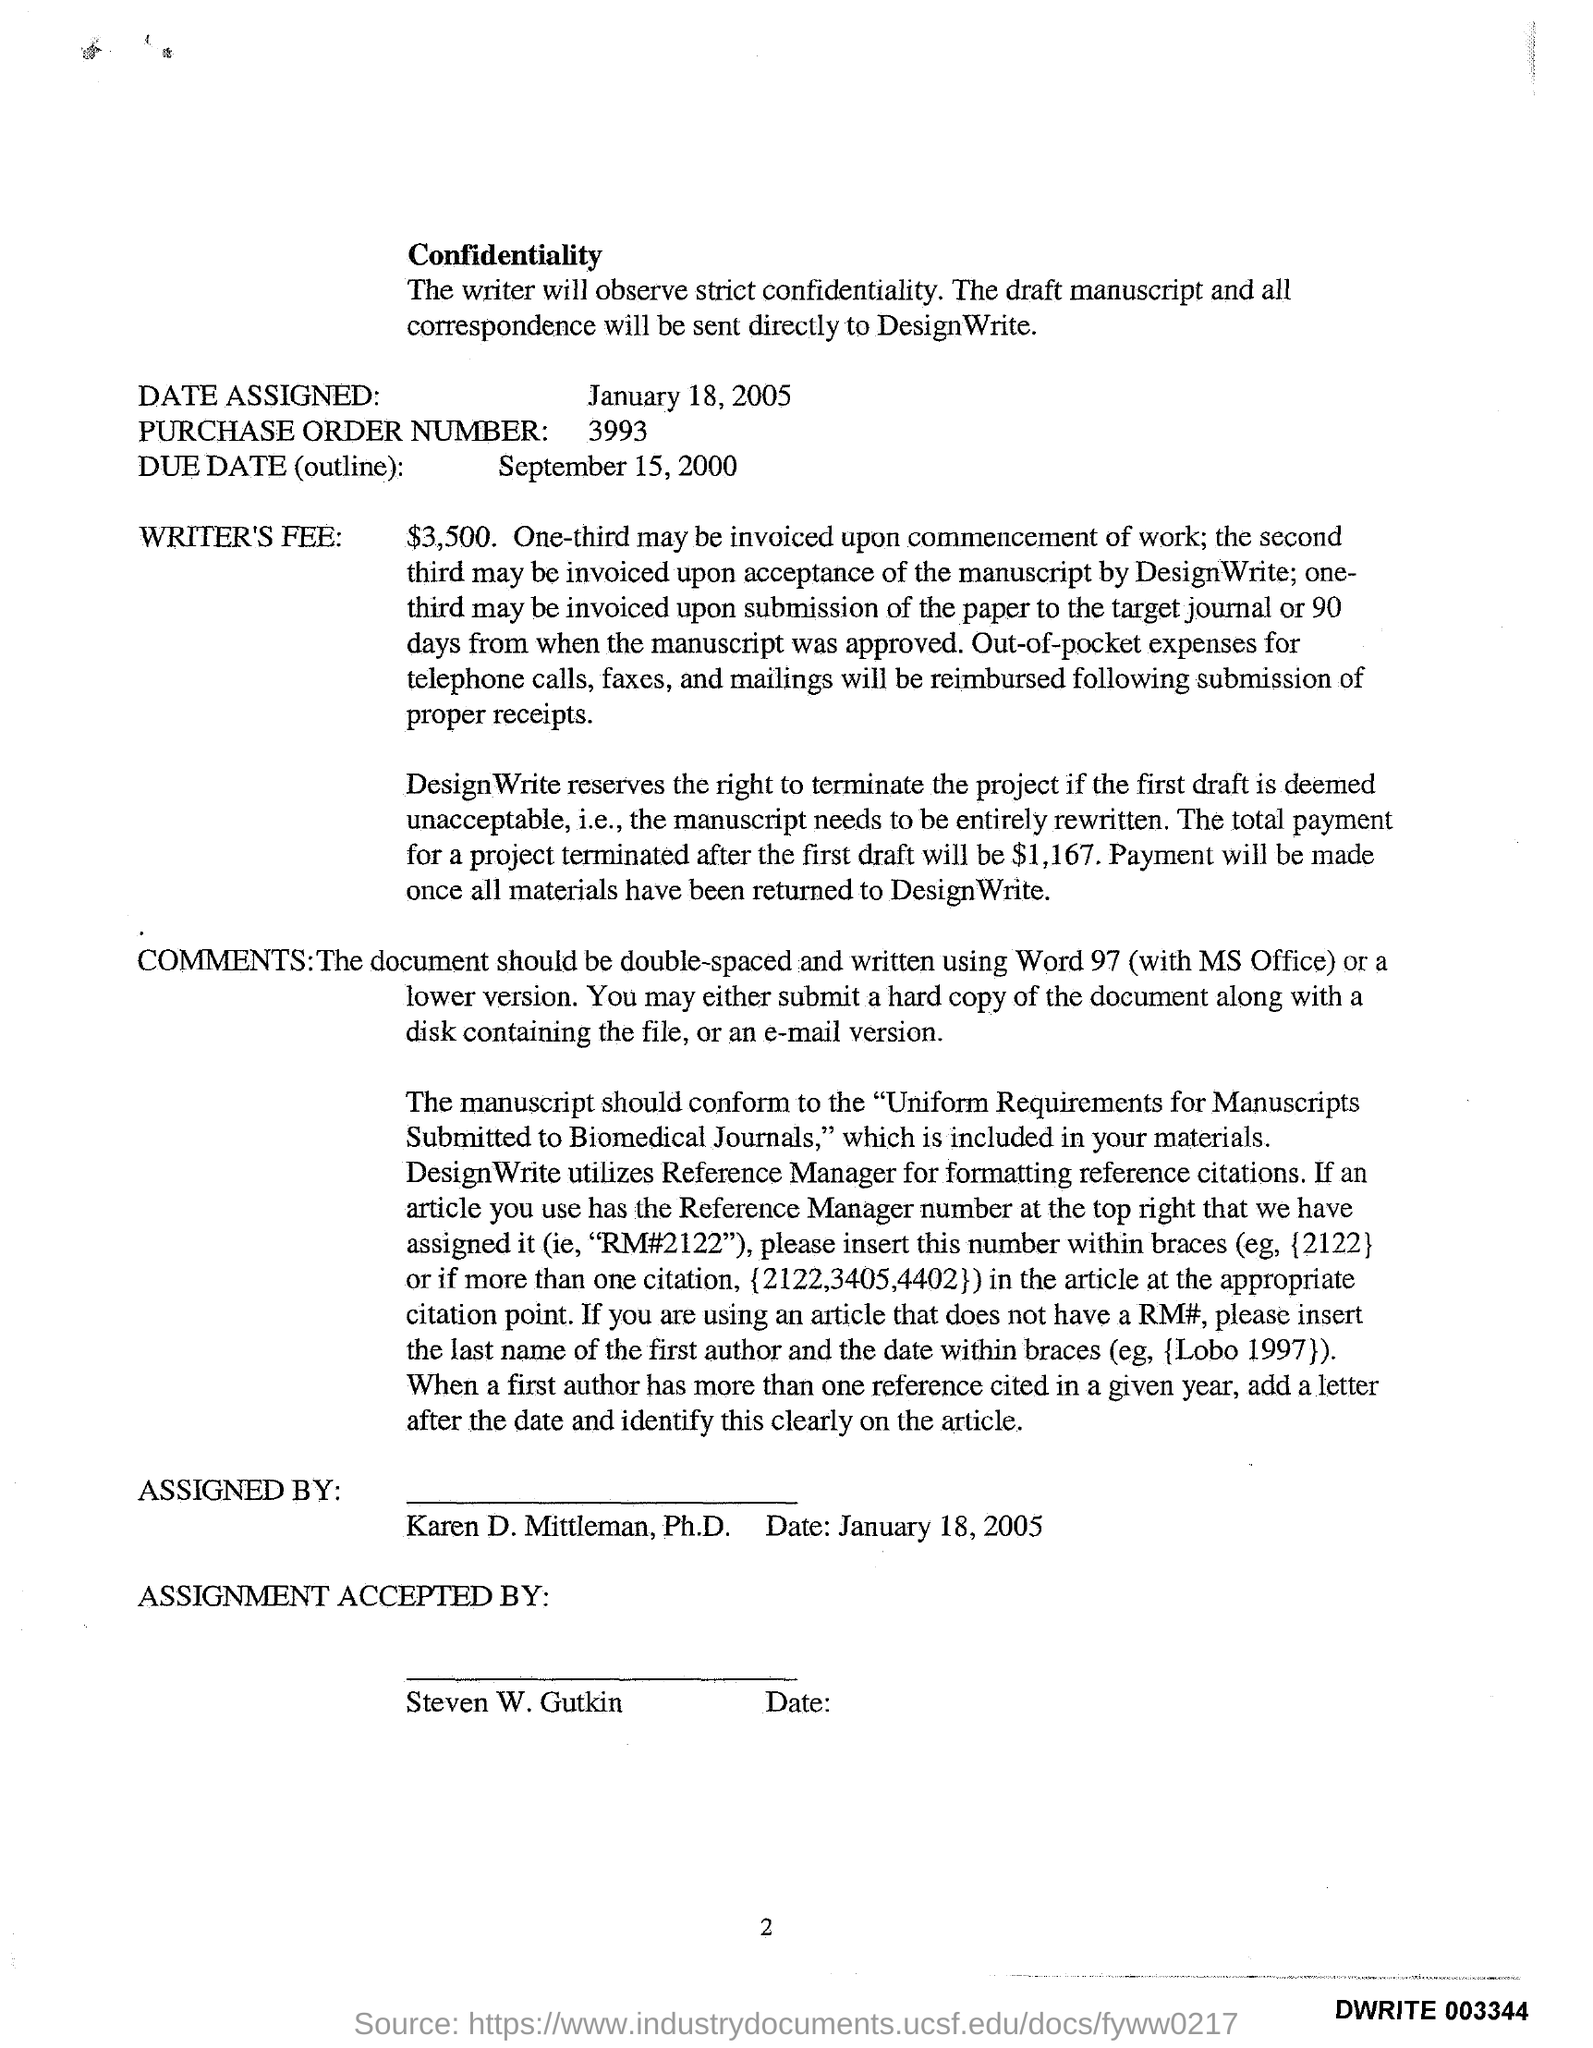Identify some key points in this picture. The purchase order number is 3993. On January 18, 2005, the date was assigned. The due date for the outline is September 15, 2000. 